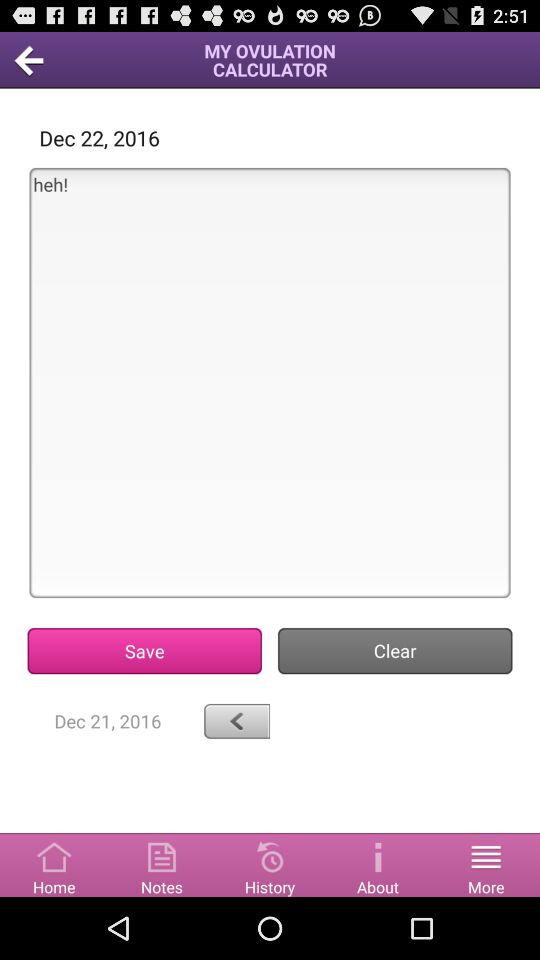What is the mentioned date? The mentioned dates are December 22, 2016 and December 21, 2016. 